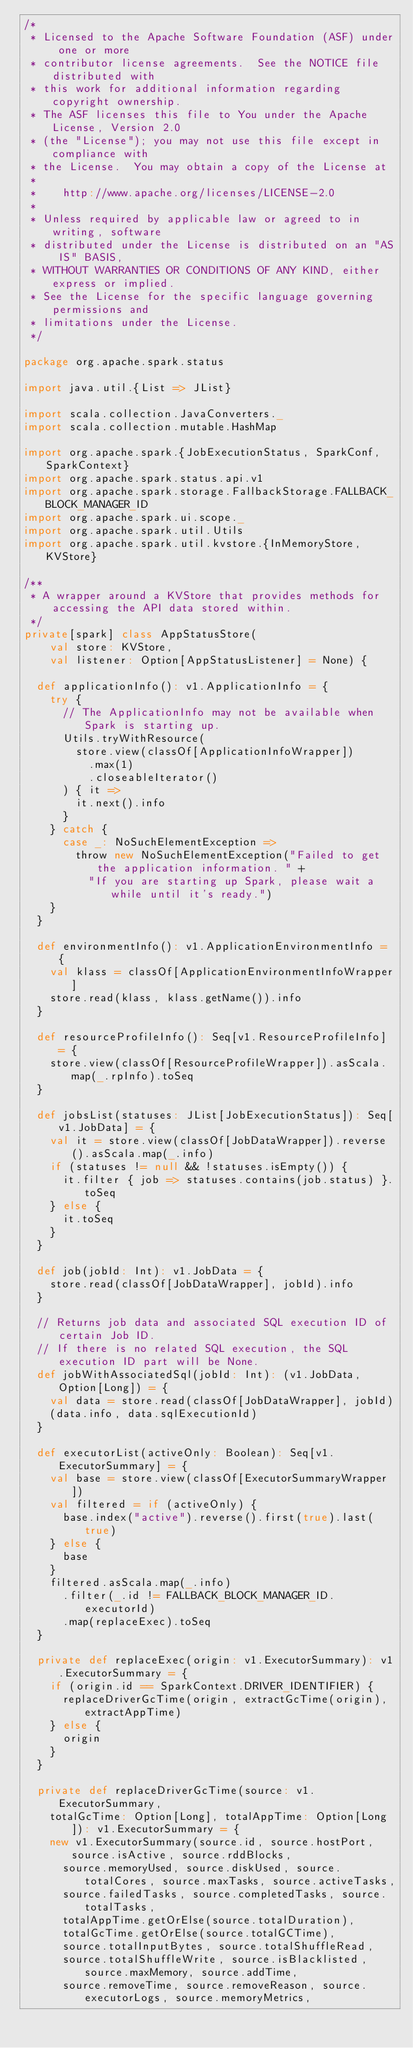Convert code to text. <code><loc_0><loc_0><loc_500><loc_500><_Scala_>/*
 * Licensed to the Apache Software Foundation (ASF) under one or more
 * contributor license agreements.  See the NOTICE file distributed with
 * this work for additional information regarding copyright ownership.
 * The ASF licenses this file to You under the Apache License, Version 2.0
 * (the "License"); you may not use this file except in compliance with
 * the License.  You may obtain a copy of the License at
 *
 *    http://www.apache.org/licenses/LICENSE-2.0
 *
 * Unless required by applicable law or agreed to in writing, software
 * distributed under the License is distributed on an "AS IS" BASIS,
 * WITHOUT WARRANTIES OR CONDITIONS OF ANY KIND, either express or implied.
 * See the License for the specific language governing permissions and
 * limitations under the License.
 */

package org.apache.spark.status

import java.util.{List => JList}

import scala.collection.JavaConverters._
import scala.collection.mutable.HashMap

import org.apache.spark.{JobExecutionStatus, SparkConf, SparkContext}
import org.apache.spark.status.api.v1
import org.apache.spark.storage.FallbackStorage.FALLBACK_BLOCK_MANAGER_ID
import org.apache.spark.ui.scope._
import org.apache.spark.util.Utils
import org.apache.spark.util.kvstore.{InMemoryStore, KVStore}

/**
 * A wrapper around a KVStore that provides methods for accessing the API data stored within.
 */
private[spark] class AppStatusStore(
    val store: KVStore,
    val listener: Option[AppStatusListener] = None) {

  def applicationInfo(): v1.ApplicationInfo = {
    try {
      // The ApplicationInfo may not be available when Spark is starting up.
      Utils.tryWithResource(
        store.view(classOf[ApplicationInfoWrapper])
          .max(1)
          .closeableIterator()
      ) { it =>
        it.next().info
      }
    } catch {
      case _: NoSuchElementException =>
        throw new NoSuchElementException("Failed to get the application information. " +
          "If you are starting up Spark, please wait a while until it's ready.")
    }
  }

  def environmentInfo(): v1.ApplicationEnvironmentInfo = {
    val klass = classOf[ApplicationEnvironmentInfoWrapper]
    store.read(klass, klass.getName()).info
  }

  def resourceProfileInfo(): Seq[v1.ResourceProfileInfo] = {
    store.view(classOf[ResourceProfileWrapper]).asScala.map(_.rpInfo).toSeq
  }

  def jobsList(statuses: JList[JobExecutionStatus]): Seq[v1.JobData] = {
    val it = store.view(classOf[JobDataWrapper]).reverse().asScala.map(_.info)
    if (statuses != null && !statuses.isEmpty()) {
      it.filter { job => statuses.contains(job.status) }.toSeq
    } else {
      it.toSeq
    }
  }

  def job(jobId: Int): v1.JobData = {
    store.read(classOf[JobDataWrapper], jobId).info
  }

  // Returns job data and associated SQL execution ID of certain Job ID.
  // If there is no related SQL execution, the SQL execution ID part will be None.
  def jobWithAssociatedSql(jobId: Int): (v1.JobData, Option[Long]) = {
    val data = store.read(classOf[JobDataWrapper], jobId)
    (data.info, data.sqlExecutionId)
  }

  def executorList(activeOnly: Boolean): Seq[v1.ExecutorSummary] = {
    val base = store.view(classOf[ExecutorSummaryWrapper])
    val filtered = if (activeOnly) {
      base.index("active").reverse().first(true).last(true)
    } else {
      base
    }
    filtered.asScala.map(_.info)
      .filter(_.id != FALLBACK_BLOCK_MANAGER_ID.executorId)
      .map(replaceExec).toSeq
  }

  private def replaceExec(origin: v1.ExecutorSummary): v1.ExecutorSummary = {
    if (origin.id == SparkContext.DRIVER_IDENTIFIER) {
      replaceDriverGcTime(origin, extractGcTime(origin), extractAppTime)
    } else {
      origin
    }
  }

  private def replaceDriverGcTime(source: v1.ExecutorSummary,
    totalGcTime: Option[Long], totalAppTime: Option[Long]): v1.ExecutorSummary = {
    new v1.ExecutorSummary(source.id, source.hostPort, source.isActive, source.rddBlocks,
      source.memoryUsed, source.diskUsed, source.totalCores, source.maxTasks, source.activeTasks,
      source.failedTasks, source.completedTasks, source.totalTasks,
      totalAppTime.getOrElse(source.totalDuration),
      totalGcTime.getOrElse(source.totalGCTime),
      source.totalInputBytes, source.totalShuffleRead,
      source.totalShuffleWrite, source.isBlacklisted, source.maxMemory, source.addTime,
      source.removeTime, source.removeReason, source.executorLogs, source.memoryMetrics,</code> 